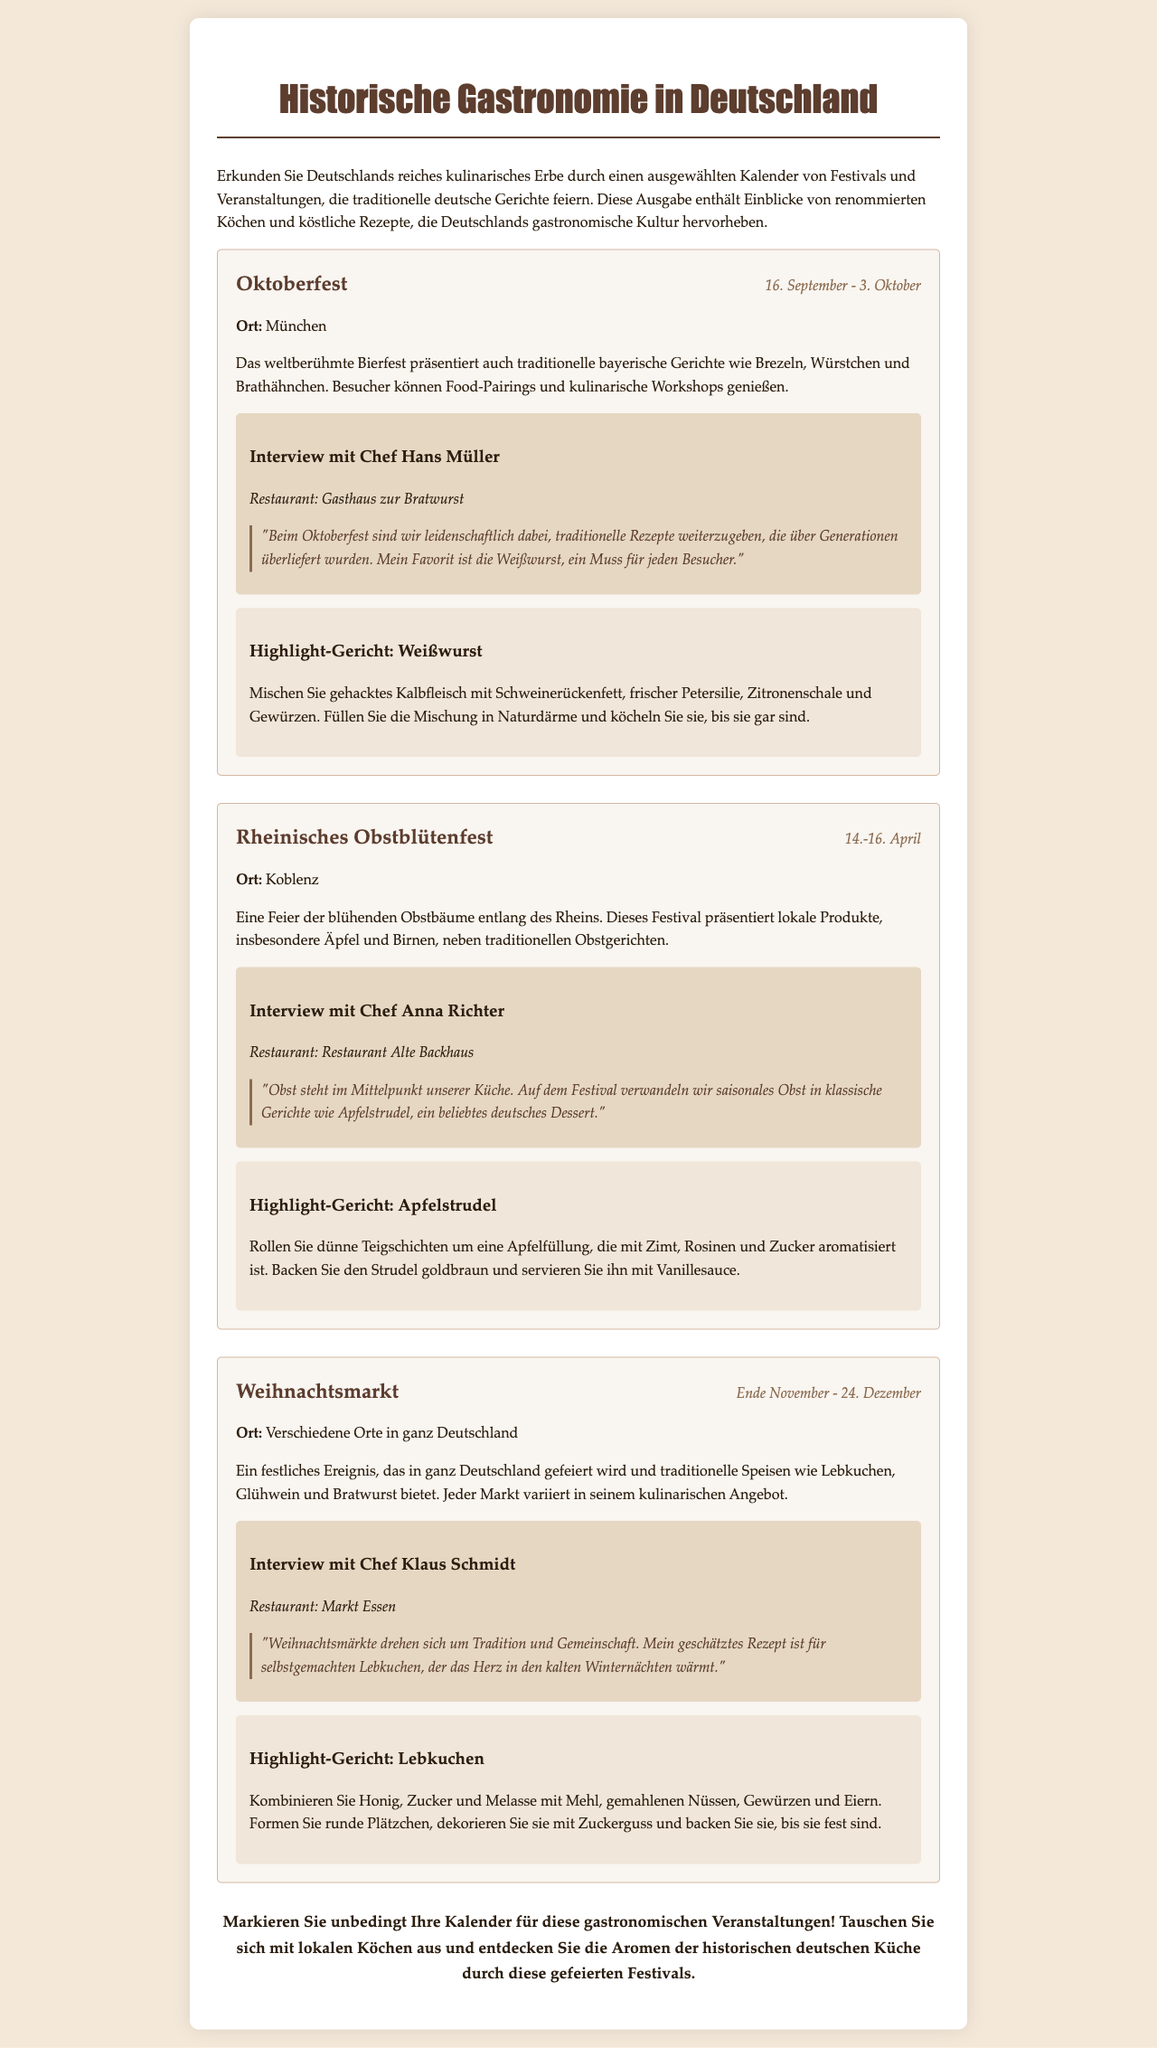What is the date range of the Oktoberfest? The date range for Oktoberfest as mentioned in the document is from September 16 to October 3.
Answer: September 16 - October 3 Where is the Rheinisches Obstblütenfest held? The document specifies that the Rheinisches Obstblütenfest takes place in Koblenz.
Answer: Koblenz Who is the chef interviewed for the Oktoberfest? Chef Hans Müller is the one interviewed for the Oktoberfest in the newsletter.
Answer: Hans Müller What traditional dish is highlighted at the Weihnachtsmarkt? The highlight dish mentioned for the Weihnachtsmarkt is Lebkuchen.
Answer: Lebkuchen Which festival focuses on seasonal fruits? The Rheinisches Obstblütenfest is focused on celebrating seasonal fruits, particularly apples and pears.
Answer: Rheinisches Obstblütenfest What is Chef Klaus Schmidt’s cherished recipe? Chef Klaus Schmidt expresses his appreciation for a recipe for homemade Lebkuchen during the interview.
Answer: Lebkuchen How long does the Weihnachtsmarkt last? The duration of the Weihnachtsmarkt is from late November until December 24.
Answer: Ende November - 24. Dezember What type of food is primarily featured at the Oktoberfest? Traditional Bavarian dishes such as Brezeln, Würstchen, and Brathähnchen are primarily featured at the Oktoberfest.
Answer: Brezeln, Würstchen, Brathähnchen Which dessert is made with a mixture of apples and cinnamon? The dessert made with apples and cinnamon is Apfelstrudel, as mentioned in the document.
Answer: Apfelstrudel 